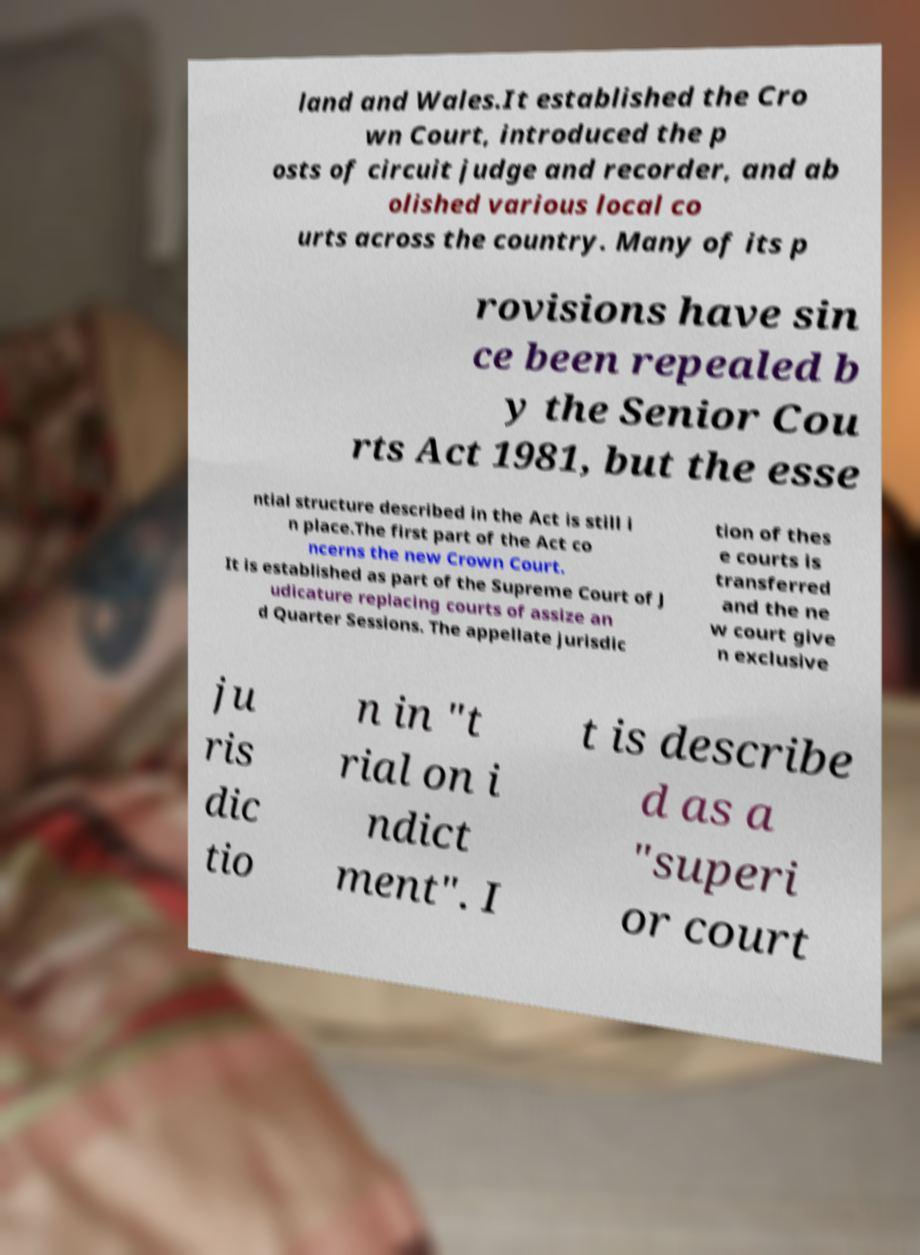Could you assist in decoding the text presented in this image and type it out clearly? land and Wales.It established the Cro wn Court, introduced the p osts of circuit judge and recorder, and ab olished various local co urts across the country. Many of its p rovisions have sin ce been repealed b y the Senior Cou rts Act 1981, but the esse ntial structure described in the Act is still i n place.The first part of the Act co ncerns the new Crown Court. It is established as part of the Supreme Court of J udicature replacing courts of assize an d Quarter Sessions. The appellate jurisdic tion of thes e courts is transferred and the ne w court give n exclusive ju ris dic tio n in "t rial on i ndict ment". I t is describe d as a "superi or court 